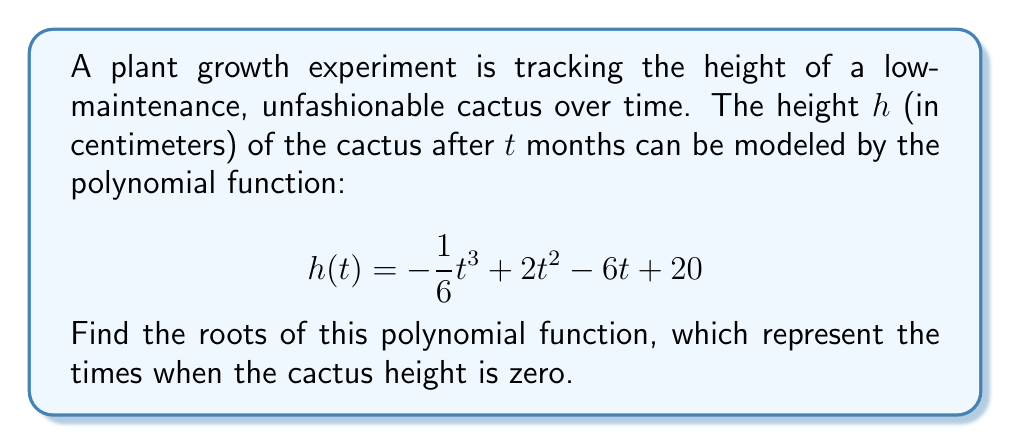Provide a solution to this math problem. To find the roots of the polynomial function, we need to solve the equation:

$$ -\frac{1}{6}t^3 + 2t^2 - 6t + 20 = 0 $$

Let's approach this step-by-step:

1) First, multiply all terms by -6 to eliminate fractions:

   $$ t^3 - 12t^2 + 36t - 120 = 0 $$

2) This is a cubic equation. One way to solve it is to guess one root and then use polynomial long division to find the other roots.

3) By inspection or trial and error, we can find that $t = 4$ is a root of this equation.

4) Divide the polynomial by $(t - 4)$:

   $$ t^3 - 12t^2 + 36t - 120 = (t - 4)(t^2 - 8t + 30) $$

5) Now we need to solve the quadratic equation:

   $$ t^2 - 8t + 30 = 0 $$

6) Use the quadratic formula: $t = \frac{-b \pm \sqrt{b^2 - 4ac}}{2a}$

   Where $a = 1$, $b = -8$, and $c = 30$

7) Substituting these values:

   $$ t = \frac{8 \pm \sqrt{64 - 120}}{2} = \frac{8 \pm \sqrt{-56}}{2} $$

8) Since the discriminant is negative, there are no real roots for this quadratic equation.

Therefore, the only real root of the original cubic equation is $t = 4$.
Answer: The only real root of the polynomial function is $t = 4$. This means the cactus height would be zero after 4 months, which is not practically possible for a growing plant. The other two roots are complex and not relevant to the physical scenario. 